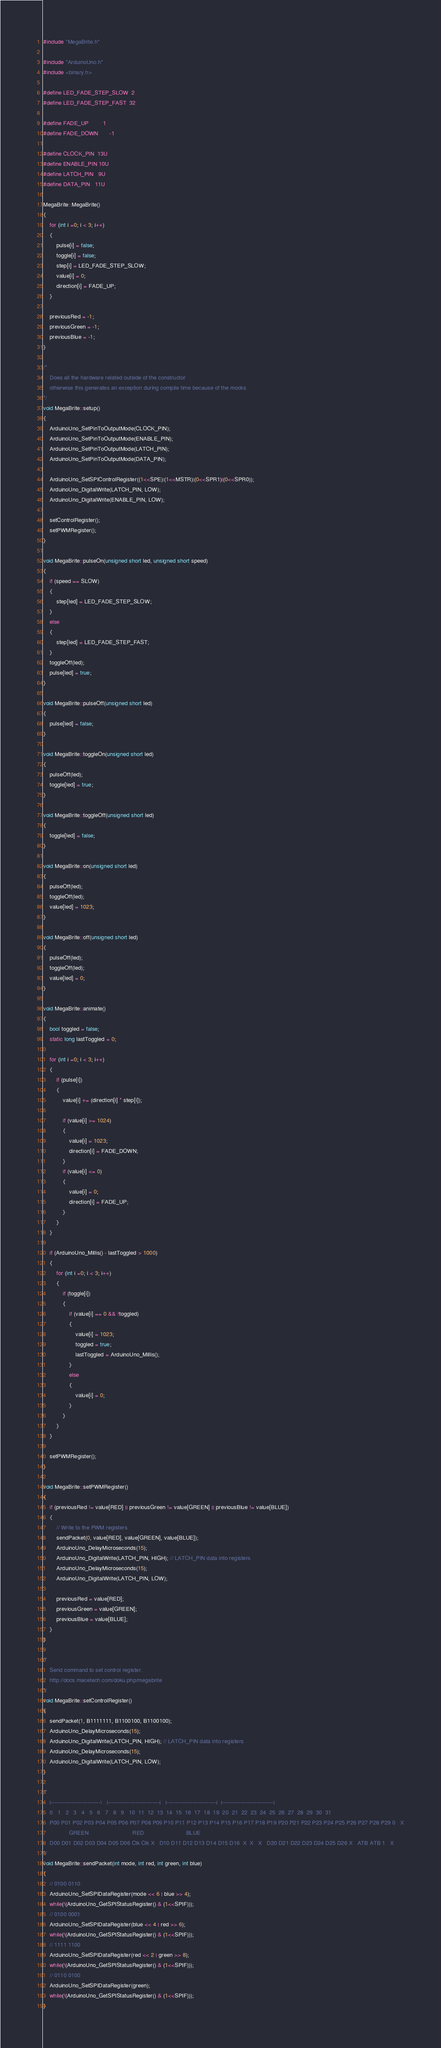Convert code to text. <code><loc_0><loc_0><loc_500><loc_500><_C++_>#include "MegaBrite.h"

#include "ArduinoUno.h"
#include <binary.h>

#define LED_FADE_STEP_SLOW  2
#define LED_FADE_STEP_FAST  32

#define FADE_UP         1
#define FADE_DOWN       -1

#define CLOCK_PIN  13U
#define ENABLE_PIN 10U
#define LATCH_PIN   9U
#define DATA_PIN   11U

MegaBrite::MegaBrite()
{
	for (int i =0; i < 3; i++)
	{
		pulse[i] = false;
		toggle[i] = false;
		step[i] = LED_FADE_STEP_SLOW;
		value[i] = 0;
		direction[i] = FADE_UP;
	}	

    previousRed = -1;
    previousGreen = -1;
    previousBlue = -1;
}

/*
	Does all the hardware related outside of the constructor
	otherwise this generates an exception during compile time because of the mocks
*/
void MegaBrite::setup()
{
	ArduinoUno_SetPinToOutputMode(CLOCK_PIN);
	ArduinoUno_SetPinToOutputMode(ENABLE_PIN);
	ArduinoUno_SetPinToOutputMode(LATCH_PIN);
	ArduinoUno_SetPinToOutputMode(DATA_PIN);

	ArduinoUno_SetSPIControlRegister((1<<SPE)|(1<<MSTR)|(0<<SPR1)|(0<<SPR0));
	ArduinoUno_DigitalWrite(LATCH_PIN, LOW);
	ArduinoUno_DigitalWrite(ENABLE_PIN, LOW);

	setControlRegister();
	setPWMRegister();
}

void MegaBrite::pulseOn(unsigned short led, unsigned short speed)
{
	if (speed == SLOW)
	{
		step[led] = LED_FADE_STEP_SLOW;
	}
	else
	{
	    step[led] = LED_FADE_STEP_FAST;		
	}
	toggleOff(led);
	pulse[led] = true;
}

void MegaBrite::pulseOff(unsigned short led)
{
	pulse[led] = false;
}

void MegaBrite::toggleOn(unsigned short led)
{
	pulseOff(led);
	toggle[led] = true;
}

void MegaBrite::toggleOff(unsigned short led)
{
	toggle[led] = false;
}

void MegaBrite::on(unsigned short led)
{
	pulseOff(led);
	toggleOff(led);
	value[led] = 1023;
}

void MegaBrite::off(unsigned short led)
{
	pulseOff(led);
	toggleOff(led);
	value[led] = 0;
}

void MegaBrite::animate()
{
	bool toggled = false;
    static long lastToggled = 0;

	for (int i =0; i < 3; i++)
	{
	    if (pulse[i])
	    {
	        value[i] += (direction[i] * step[i]);	        

	        if (value[i] >= 1024)
	        {
	        	value[i] = 1023;
	            direction[i] = FADE_DOWN;
	        }
	        if (value[i] <= 0)
	        {
	        	value[i] = 0;
	            direction[i] = FADE_UP;
	        }
	    }		
	}

	if (ArduinoUno_Millis() - lastToggled > 1000)
	{
		for (int i =0; i < 3; i++)
		{
		    if (toggle[i])
		    {
		        if (value[i] == 0 && !toggled)
		        {
		        	value[i] = 1023;
		        	toggled = true;
	                lastToggled = ArduinoUno_Millis();
		        }
		        else
		        {
		        	value[i] = 0;
		        }
		    }		
		}		
	}

	setPWMRegister();
}

void MegaBrite::setPWMRegister()
{
	if (previousRed != value[RED] || previousGreen != value[GREEN] || previousBlue != value[BLUE])
	{
		// Write to the PWM registers
		sendPacket(0, value[RED], value[GREEN], value[BLUE]);
		ArduinoUno_DelayMicroseconds(15);
	    ArduinoUno_DigitalWrite(LATCH_PIN, HIGH); // LATCH_PIN data into registers
	    ArduinoUno_DelayMicroseconds(15);
	    ArduinoUno_DigitalWrite(LATCH_PIN, LOW);

	    previousRed = value[RED];
	    previousGreen = value[GREEN];
	    previousBlue = value[BLUE];
	}
}

/*
	Send command to set control register.
	http://docs.macetech.com/doku.php/megabrite
*/
void MegaBrite::setControlRegister()
{
	sendPacket(1, B1111111, B1100100, B1100100);
	ArduinoUno_DelayMicroseconds(15);
    ArduinoUno_DigitalWrite(LATCH_PIN, HIGH); // LATCH_PIN data into registers
    ArduinoUno_DelayMicroseconds(15);
    ArduinoUno_DigitalWrite(LATCH_PIN, LOW);    
}

/*
    |---------------------------\   |----------------------------|   |---------------------------|  |----------------------------|
	0	1	2	3	4	5	6	7	8	9	10	11	12	13	14	15	16	17	18	19	20	21	22	23	24	25	26	27	28	29	30	31
	P00 P01 P02 P03 P04 P05 P06 P07 P08 P09 P10 P11 P12 P13 P14 P15 P16 P17 P18 P19 P20 P21 P22 P23 P24 P25 P26 P27 P28 P29 0	X
                GREEN                           RED                          BLUE
	D00 D01 D02 D03 D04 D05 D06 Clk	Clk X	D10 D11 D12 D13 D14 D15 D16  X	X	X	D20 D21 D22 D23 D24 D25 D26 X	ATB	ATB	1	X
*/
void MegaBrite::sendPacket(int mode, int red, int green, int blue) 
{ 
    // 0100 0110
    ArduinoUno_SetSPIDataRegister(mode << 6 | blue >> 4);
    while(!(ArduinoUno_GetSPIStatusRegister() & (1<<SPIF)));
    // 0100 0001
    ArduinoUno_SetSPIDataRegister(blue << 4 | red >> 6);
    while(!(ArduinoUno_GetSPIStatusRegister() & (1<<SPIF)));
    // 1111 1100
    ArduinoUno_SetSPIDataRegister(red << 2 | green >> 8);
    while(!(ArduinoUno_GetSPIStatusRegister() & (1<<SPIF)));
    // 0110 0100
    ArduinoUno_SetSPIDataRegister(green);
    while(!(ArduinoUno_GetSPIStatusRegister() & (1<<SPIF)));
}
</code> 